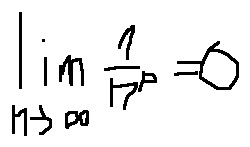<formula> <loc_0><loc_0><loc_500><loc_500>\lim \lim i t s _ { n \rightarrow \infty } \frac { 1 } { n ^ { p } } = 0</formula> 